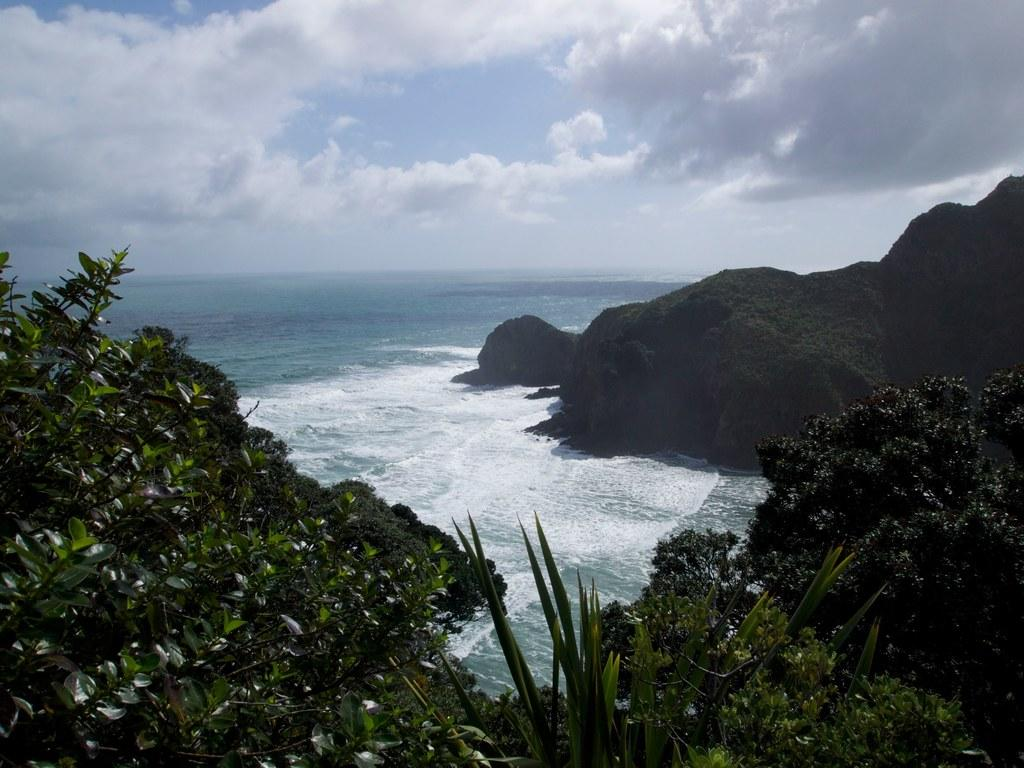What is visible in the image? Water and trees are visible in the image. What can be seen in the background of the image? There are clouds in the background of the image. How many snails can be seen crawling on the trees in the image? There are no snails visible in the image; it only features water, trees, and clouds. 